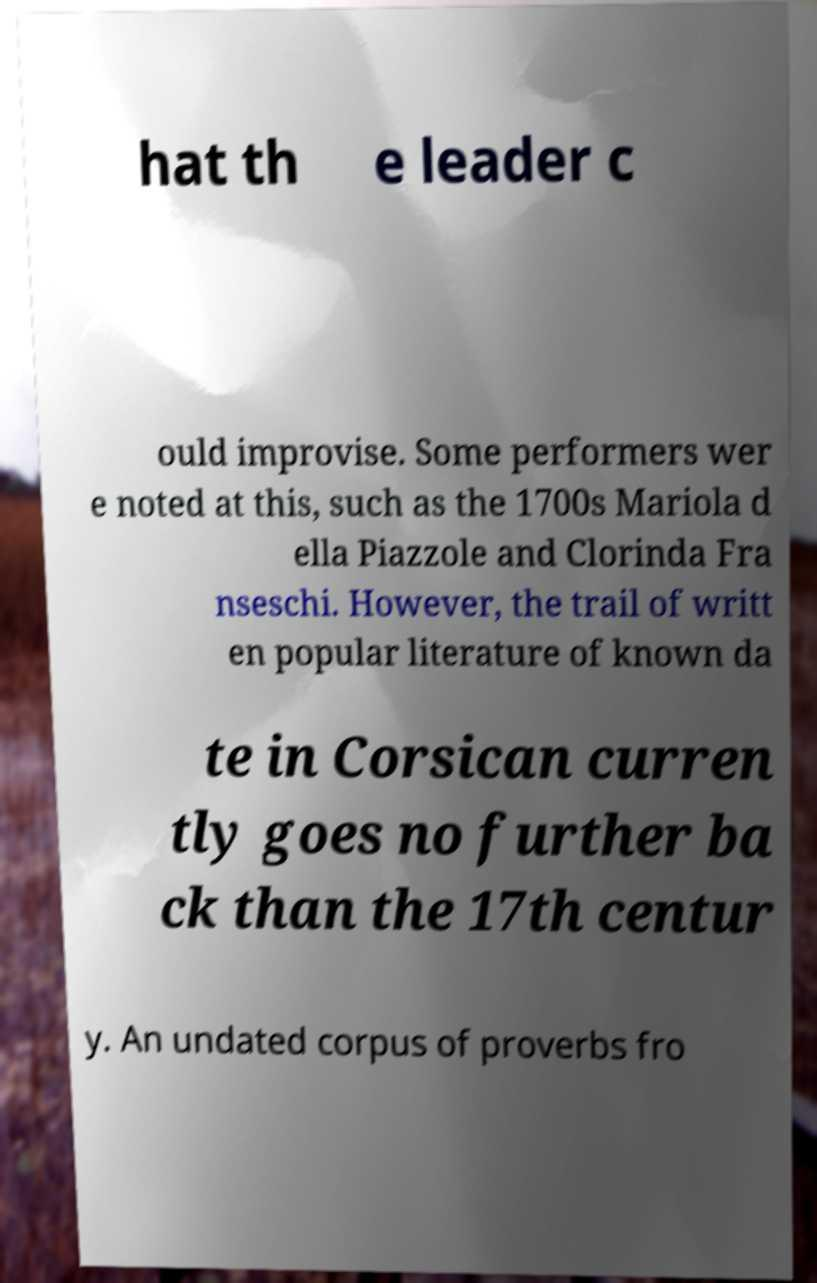Can you accurately transcribe the text from the provided image for me? hat th e leader c ould improvise. Some performers wer e noted at this, such as the 1700s Mariola d ella Piazzole and Clorinda Fra nseschi. However, the trail of writt en popular literature of known da te in Corsican curren tly goes no further ba ck than the 17th centur y. An undated corpus of proverbs fro 